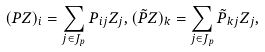<formula> <loc_0><loc_0><loc_500><loc_500>( { P } Z ) _ { i } = \sum _ { j \in J _ { p } } P _ { i j } { Z _ { j } } , ( { \tilde { P } } Z ) _ { k } = \sum _ { j \in J _ { p } } \tilde { P } _ { k j } Z _ { j } ,</formula> 